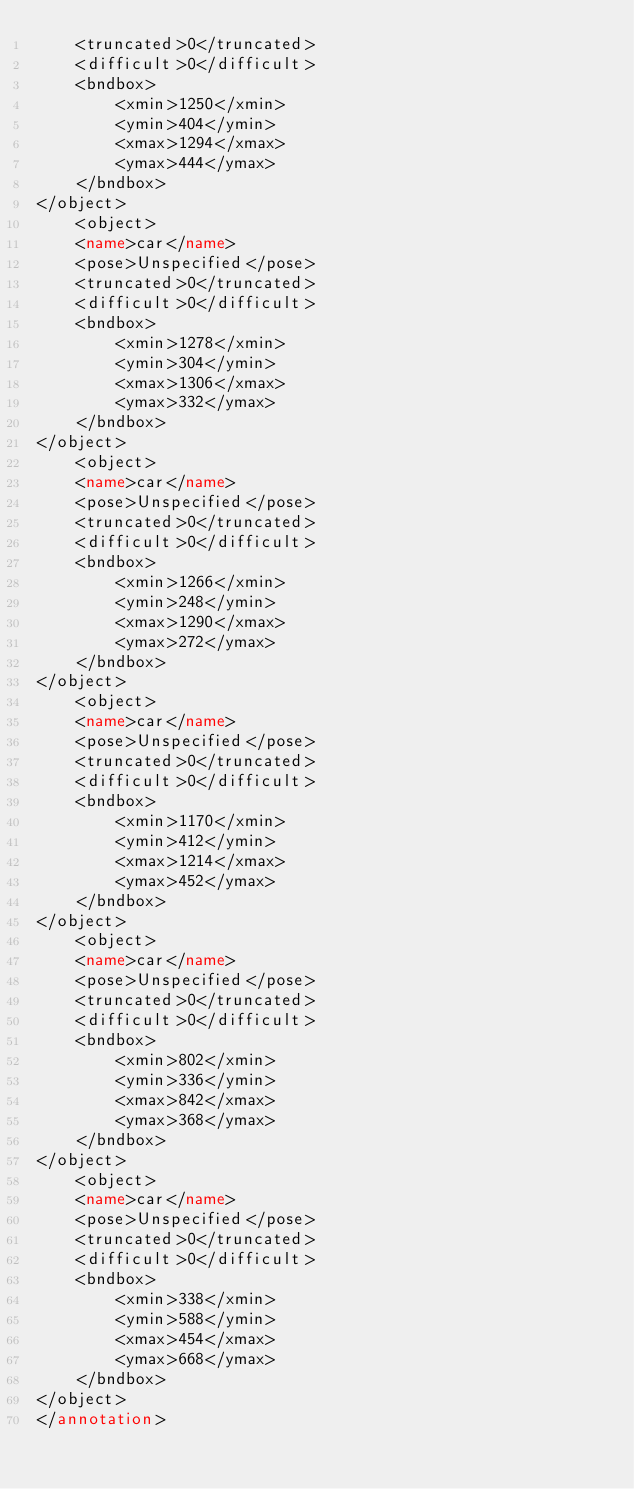<code> <loc_0><loc_0><loc_500><loc_500><_XML_>    <truncated>0</truncated>
    <difficult>0</difficult>
    <bndbox>
        <xmin>1250</xmin>
        <ymin>404</ymin>
        <xmax>1294</xmax>
        <ymax>444</ymax>
    </bndbox>
</object>
    <object>
    <name>car</name>
    <pose>Unspecified</pose>
    <truncated>0</truncated>
    <difficult>0</difficult>
    <bndbox>
        <xmin>1278</xmin>
        <ymin>304</ymin>
        <xmax>1306</xmax>
        <ymax>332</ymax>
    </bndbox>
</object>
    <object>
    <name>car</name>
    <pose>Unspecified</pose>
    <truncated>0</truncated>
    <difficult>0</difficult>
    <bndbox>
        <xmin>1266</xmin>
        <ymin>248</ymin>
        <xmax>1290</xmax>
        <ymax>272</ymax>
    </bndbox>
</object>
    <object>
    <name>car</name>
    <pose>Unspecified</pose>
    <truncated>0</truncated>
    <difficult>0</difficult>
    <bndbox>
        <xmin>1170</xmin>
        <ymin>412</ymin>
        <xmax>1214</xmax>
        <ymax>452</ymax>
    </bndbox>
</object>
    <object>
    <name>car</name>
    <pose>Unspecified</pose>
    <truncated>0</truncated>
    <difficult>0</difficult>
    <bndbox>
        <xmin>802</xmin>
        <ymin>336</ymin>
        <xmax>842</xmax>
        <ymax>368</ymax>
    </bndbox>
</object>
    <object>
    <name>car</name>
    <pose>Unspecified</pose>
    <truncated>0</truncated>
    <difficult>0</difficult>
    <bndbox>
        <xmin>338</xmin>
        <ymin>588</ymin>
        <xmax>454</xmax>
        <ymax>668</ymax>
    </bndbox>
</object>
</annotation></code> 